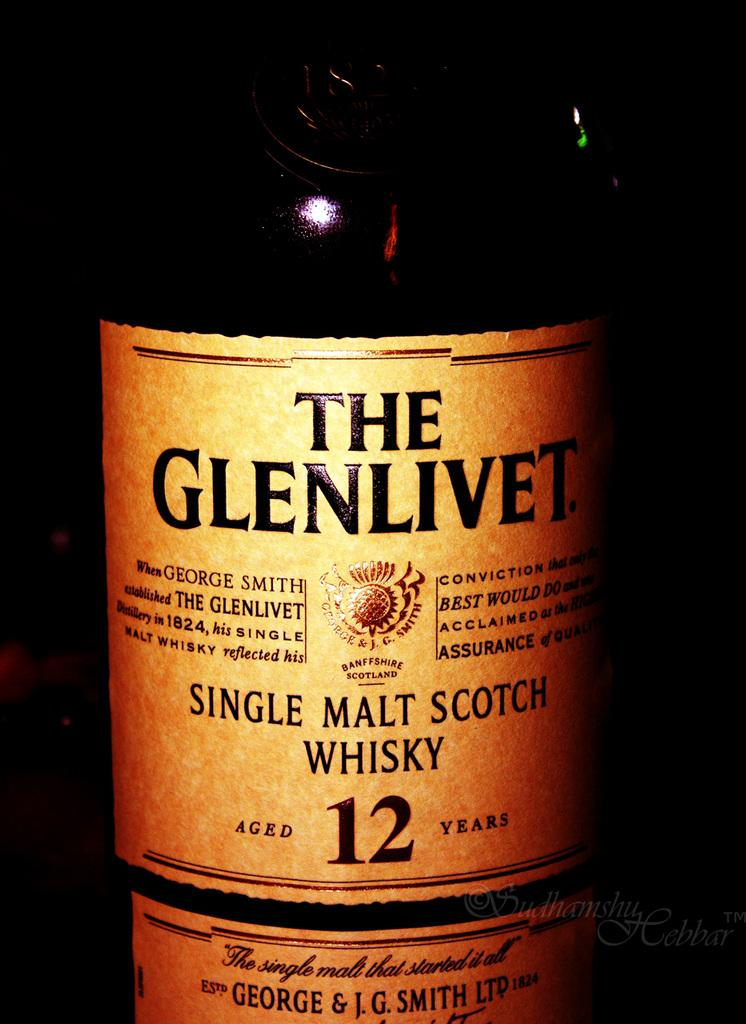<image>
Offer a succinct explanation of the picture presented. A bottle of The Glenlivet says on the label that it was aged 12 years. 